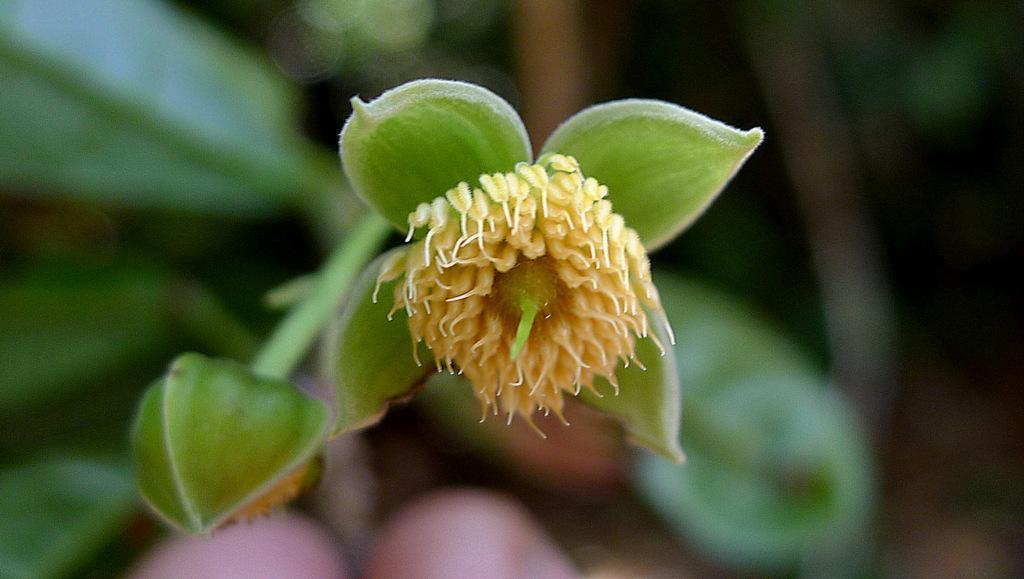How would you summarize this image in a sentence or two? In this image I can see there are pollen grains in this flower, on the left side it is the bud. 